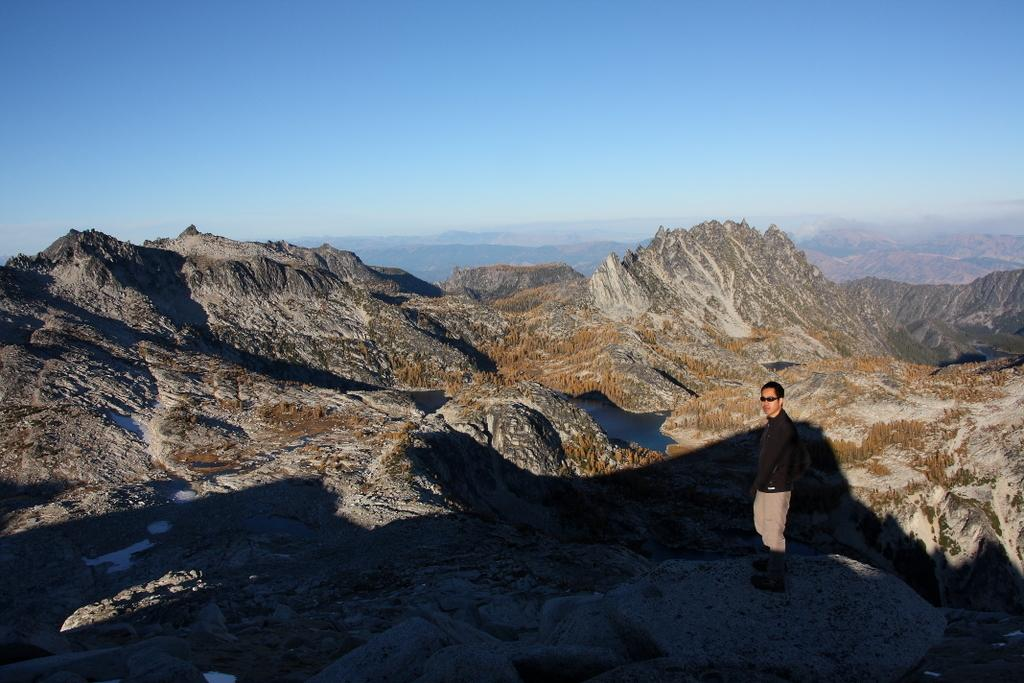Who or what is on the right side of the image? There is a person on the right side of the image. What can be seen in the distance behind the person? There are mountains in the background of the image. What is visible at the top of the image? The sky is visible at the top of the image. What type of calculator is being used by the person in the image? There is no calculator present in the image; the person is not using any device or tool. 